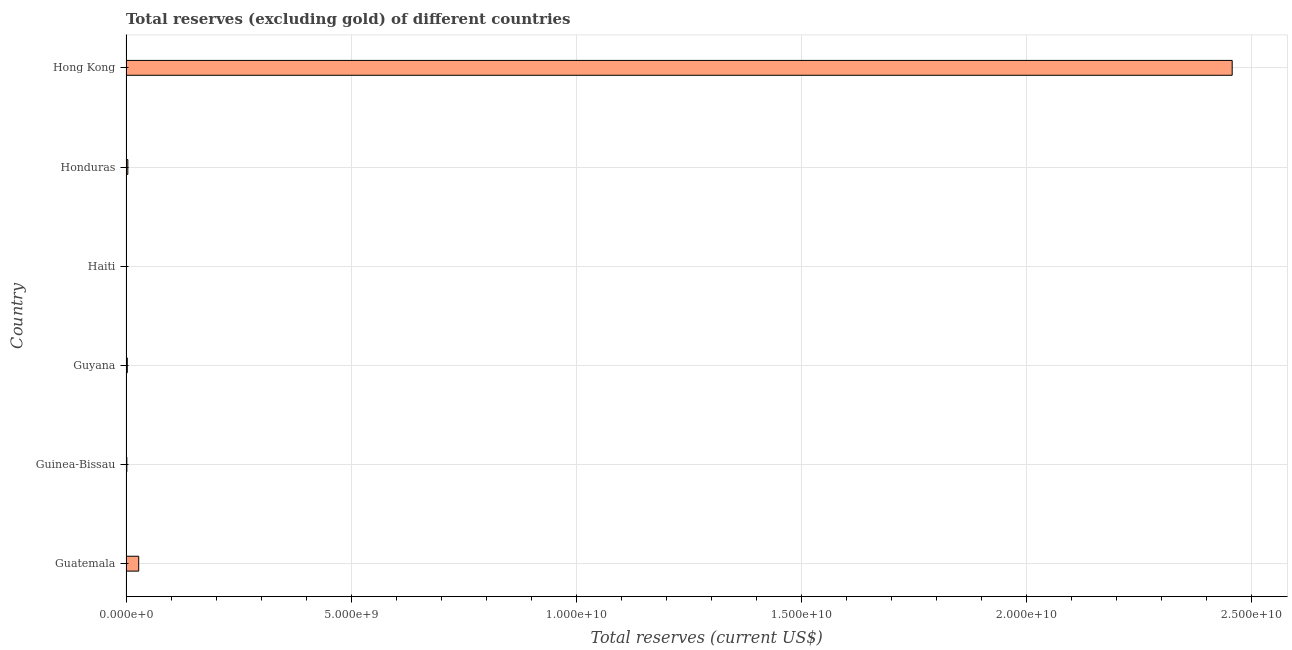What is the title of the graph?
Provide a short and direct response. Total reserves (excluding gold) of different countries. What is the label or title of the X-axis?
Provide a succinct answer. Total reserves (current US$). What is the label or title of the Y-axis?
Give a very brief answer. Country. What is the total reserves (excluding gold) in Haiti?
Offer a very short reply. 3.17e+06. Across all countries, what is the maximum total reserves (excluding gold)?
Ensure brevity in your answer.  2.46e+1. Across all countries, what is the minimum total reserves (excluding gold)?
Ensure brevity in your answer.  3.17e+06. In which country was the total reserves (excluding gold) maximum?
Give a very brief answer. Hong Kong. In which country was the total reserves (excluding gold) minimum?
Give a very brief answer. Haiti. What is the sum of the total reserves (excluding gold)?
Your answer should be very brief. 2.49e+1. What is the difference between the total reserves (excluding gold) in Guatemala and Guyana?
Your response must be concise. 2.53e+08. What is the average total reserves (excluding gold) per country?
Make the answer very short. 4.16e+09. What is the median total reserves (excluding gold)?
Your answer should be very brief. 3.45e+07. What is the ratio of the total reserves (excluding gold) in Guatemala to that in Guinea-Bissau?
Provide a short and direct response. 15.48. Is the total reserves (excluding gold) in Guatemala less than that in Guyana?
Your answer should be very brief. No. Is the difference between the total reserves (excluding gold) in Guyana and Haiti greater than the difference between any two countries?
Provide a short and direct response. No. What is the difference between the highest and the second highest total reserves (excluding gold)?
Your answer should be compact. 2.43e+1. Is the sum of the total reserves (excluding gold) in Guinea-Bissau and Haiti greater than the maximum total reserves (excluding gold) across all countries?
Give a very brief answer. No. What is the difference between the highest and the lowest total reserves (excluding gold)?
Keep it short and to the point. 2.46e+1. What is the difference between two consecutive major ticks on the X-axis?
Ensure brevity in your answer.  5.00e+09. Are the values on the major ticks of X-axis written in scientific E-notation?
Give a very brief answer. Yes. What is the Total reserves (current US$) in Guatemala?
Offer a terse response. 2.82e+08. What is the Total reserves (current US$) of Guinea-Bissau?
Your answer should be very brief. 1.82e+07. What is the Total reserves (current US$) in Guyana?
Ensure brevity in your answer.  2.87e+07. What is the Total reserves (current US$) in Haiti?
Offer a terse response. 3.17e+06. What is the Total reserves (current US$) in Honduras?
Your response must be concise. 4.04e+07. What is the Total reserves (current US$) in Hong Kong?
Your response must be concise. 2.46e+1. What is the difference between the Total reserves (current US$) in Guatemala and Guinea-Bissau?
Your answer should be compact. 2.64e+08. What is the difference between the Total reserves (current US$) in Guatemala and Guyana?
Ensure brevity in your answer.  2.53e+08. What is the difference between the Total reserves (current US$) in Guatemala and Haiti?
Your answer should be compact. 2.79e+08. What is the difference between the Total reserves (current US$) in Guatemala and Honduras?
Offer a very short reply. 2.42e+08. What is the difference between the Total reserves (current US$) in Guatemala and Hong Kong?
Your answer should be compact. -2.43e+1. What is the difference between the Total reserves (current US$) in Guinea-Bissau and Guyana?
Offer a very short reply. -1.05e+07. What is the difference between the Total reserves (current US$) in Guinea-Bissau and Haiti?
Your response must be concise. 1.50e+07. What is the difference between the Total reserves (current US$) in Guinea-Bissau and Honduras?
Your response must be concise. -2.22e+07. What is the difference between the Total reserves (current US$) in Guinea-Bissau and Hong Kong?
Keep it short and to the point. -2.45e+1. What is the difference between the Total reserves (current US$) in Guyana and Haiti?
Give a very brief answer. 2.55e+07. What is the difference between the Total reserves (current US$) in Guyana and Honduras?
Provide a short and direct response. -1.17e+07. What is the difference between the Total reserves (current US$) in Guyana and Hong Kong?
Provide a succinct answer. -2.45e+1. What is the difference between the Total reserves (current US$) in Haiti and Honduras?
Give a very brief answer. -3.72e+07. What is the difference between the Total reserves (current US$) in Haiti and Hong Kong?
Offer a very short reply. -2.46e+1. What is the difference between the Total reserves (current US$) in Honduras and Hong Kong?
Your response must be concise. -2.45e+1. What is the ratio of the Total reserves (current US$) in Guatemala to that in Guinea-Bissau?
Your answer should be compact. 15.48. What is the ratio of the Total reserves (current US$) in Guatemala to that in Guyana?
Your answer should be compact. 9.83. What is the ratio of the Total reserves (current US$) in Guatemala to that in Haiti?
Offer a terse response. 88.93. What is the ratio of the Total reserves (current US$) in Guatemala to that in Honduras?
Your answer should be compact. 6.98. What is the ratio of the Total reserves (current US$) in Guatemala to that in Hong Kong?
Provide a succinct answer. 0.01. What is the ratio of the Total reserves (current US$) in Guinea-Bissau to that in Guyana?
Make the answer very short. 0.64. What is the ratio of the Total reserves (current US$) in Guinea-Bissau to that in Haiti?
Your answer should be very brief. 5.75. What is the ratio of the Total reserves (current US$) in Guinea-Bissau to that in Honduras?
Your answer should be very brief. 0.45. What is the ratio of the Total reserves (current US$) in Guyana to that in Haiti?
Your answer should be compact. 9.04. What is the ratio of the Total reserves (current US$) in Guyana to that in Honduras?
Ensure brevity in your answer.  0.71. What is the ratio of the Total reserves (current US$) in Guyana to that in Hong Kong?
Ensure brevity in your answer.  0. What is the ratio of the Total reserves (current US$) in Haiti to that in Honduras?
Provide a short and direct response. 0.08. What is the ratio of the Total reserves (current US$) in Honduras to that in Hong Kong?
Your answer should be very brief. 0. 